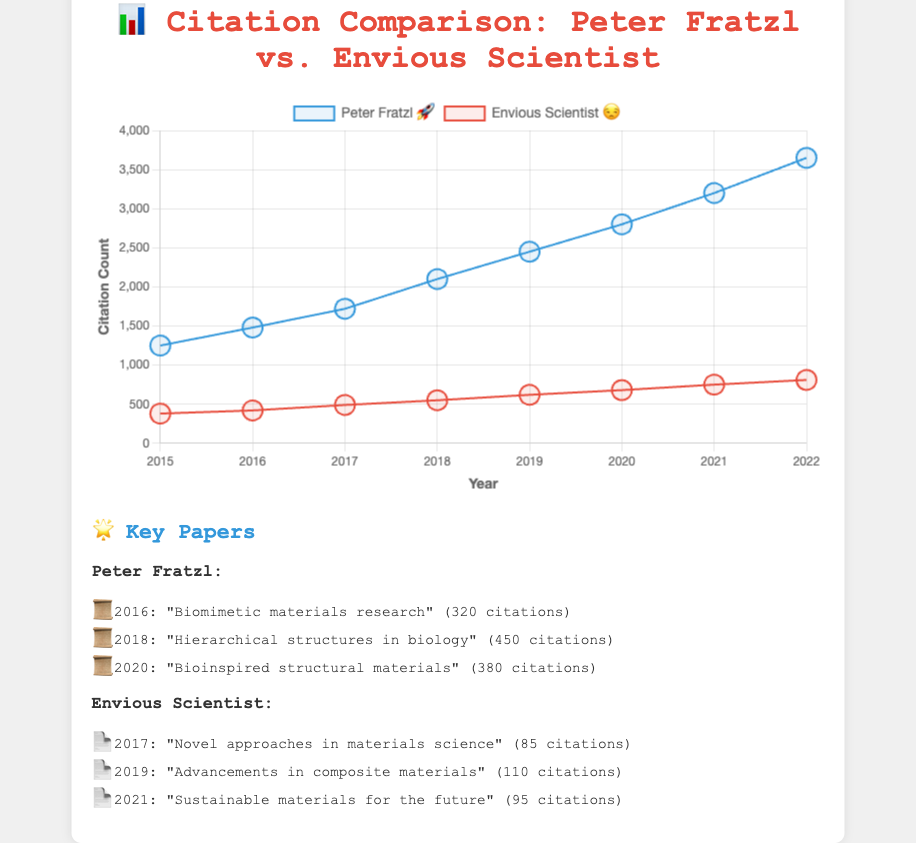What's the title of the figure? 📊 The title is clearly displayed at the top of the figure.
Answer: Citation Comparison: Peter Fratzl vs. Envious Scientist What is the citation count for Peter Fratzl in 2020? 🔢 Look at the data points for the blue line (representing Peter Fratzl) above the year 2020 on the x-axis.
Answer: 2800 How many citations did the envious scientist receive in 2019? 📉 Look at the data points for the red line (representing the envious scientist) above the year 2019 on the x-axis.
Answer: 620 Which year did Peter Fratzl have the highest increase in citations compared to the previous year? 📈 Calculate the difference year-over-year for Peter Fratzl's citations and identify the year with the largest increase. (2016 - 2015 = 230, 2017 - 2016 = 240, 2018 - 2017 = 380, 2019 - 2018 = 350, 2020 - 2019 = 350, 2021 - 2020 = 400, 2022 - 2021 = 450)
Answer: 2022 How many citations did the envious scientist get in total over the years 2015-2022? 📚 Sum the citation counts of the envious scientist for the years 2015 to 2022: 380 + 420 + 490 + 550 + 620 + 680 + 750 + 810
Answer: 4700 Which key paper of Peter Fratzl received the highest number of citations and in which year was it published? 🌟 Refer to the section listing the key papers and their citations for Peter Fratzl.
Answer: "Hierarchical structures in biology" in 2018 Is the data line for Peter Fratzl rising more steeply than the line for the envious scientist? 📐 Compare the slopes of the two lines visually by looking at their steepness over the years.
Answer: Yes What are the average citations received per year by the envious scientist from 2015 to 2022? 🧮 Calculate the average by dividing the total number of citations by the number of years: 4700 citations / 8 years
Answer: 587.5 Between 2016 and 2017, did Peter Fratzl or the envious scientist have a higher increase in citation count? 📊 Calculate the change in citations from 2016 to 2017 for both, Peter Fratzl (1720 - 1480 = 240) and the envious scientist (490 - 420 = 70).
Answer: Peter Fratzl What trend can be observed for the citation counts of both Peter Fratzl and the envious scientist over the years 2015 to 2022? 📈 Observe the overall direction and pattern of the lines for both scientists from 2015 to 2022.
Answer: Both are increasing 